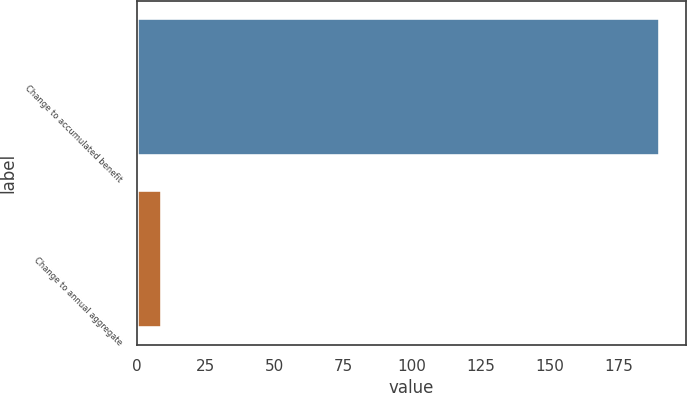<chart> <loc_0><loc_0><loc_500><loc_500><bar_chart><fcel>Change to accumulated benefit<fcel>Change to annual aggregate<nl><fcel>190<fcel>9<nl></chart> 